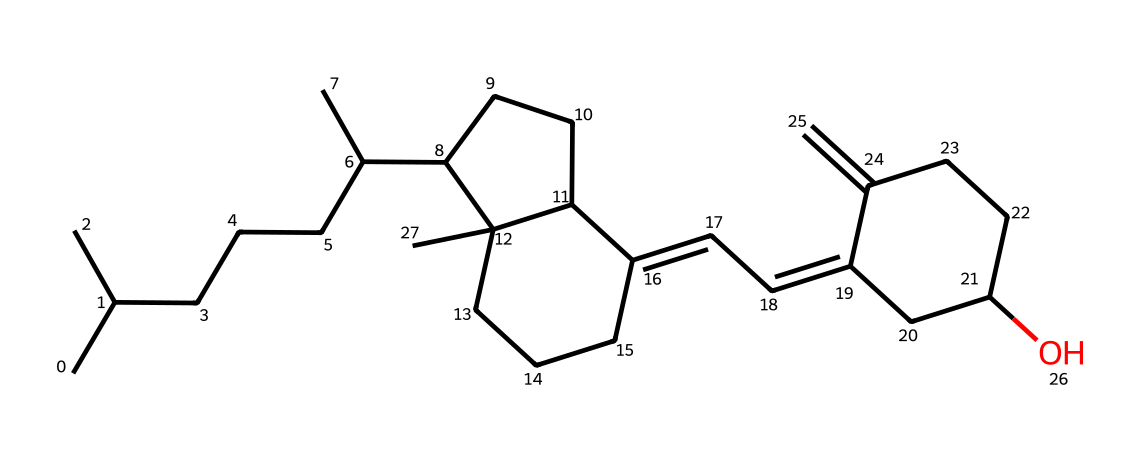What is the molecular weight of vitamin D3? To find the molecular weight, we sum the atomic weights of all the atoms in the chemical structure based on the SMILES notation. Vitamin D3 has a formula of C27H44O, which gives a molecular weight of approximately 384.65 g/mol.
Answer: 384.65 g/mol How many carbon atoms are present in this molecule? By analyzing the SMILES representation, we can count the number of carbon atoms (C) present. In this case, there are 27 carbon atoms in the structure.
Answer: 27 What functional group is present in vitamin D3? The chemical structure contains a hydroxyl group (OH), as indicated by the presence of -O in the SMILES notation. This hydroxyl group is characteristic of alcohols, which is present in vitamin D3.
Answer: hydroxyl group How does vitamin D3 impact bone health for cyclists? Vitamin D3 is crucial for calcium absorption in the gut, which is essential for maintaining bone density and strength, especially for cyclists who experience high-impact activities. This function helps prevent injuries related to bone weaknesses during cycling.
Answer: calcium absorption What type of vitamin is vitamin D3 classified as? Vitamin D3 is classified as a fat-soluble vitamin, meaning it dissolves in fats and oils and can be stored in the body's fatty tissues.
Answer: fat-soluble vitamin What is the significance of the double bond in vitamin D3's structure? The double bonds in the structure of vitamin D3 contribute to its biological activity and stability, affecting how it interacts with Vitamin D receptors in the body, which is important for its role in regulating bone health.
Answer: biological activity 